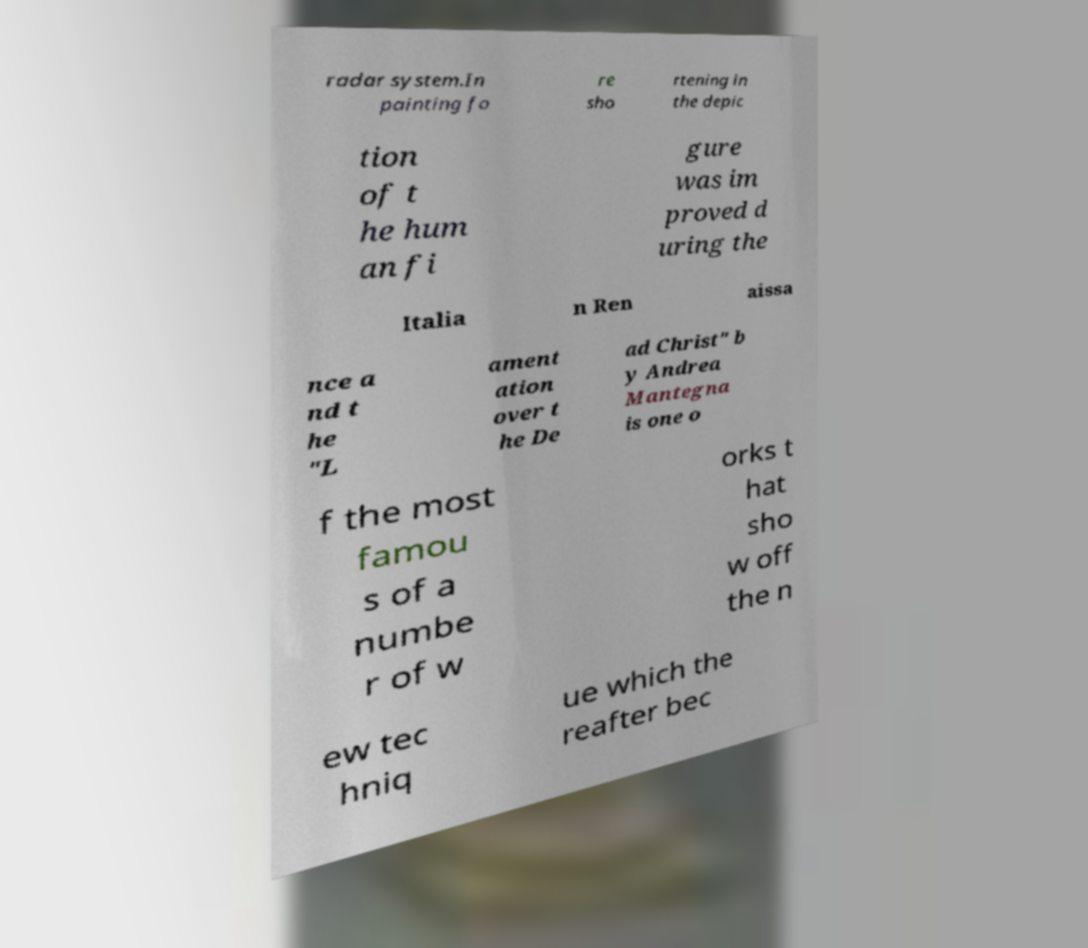Can you accurately transcribe the text from the provided image for me? radar system.In painting fo re sho rtening in the depic tion of t he hum an fi gure was im proved d uring the Italia n Ren aissa nce a nd t he "L ament ation over t he De ad Christ" b y Andrea Mantegna is one o f the most famou s of a numbe r of w orks t hat sho w off the n ew tec hniq ue which the reafter bec 